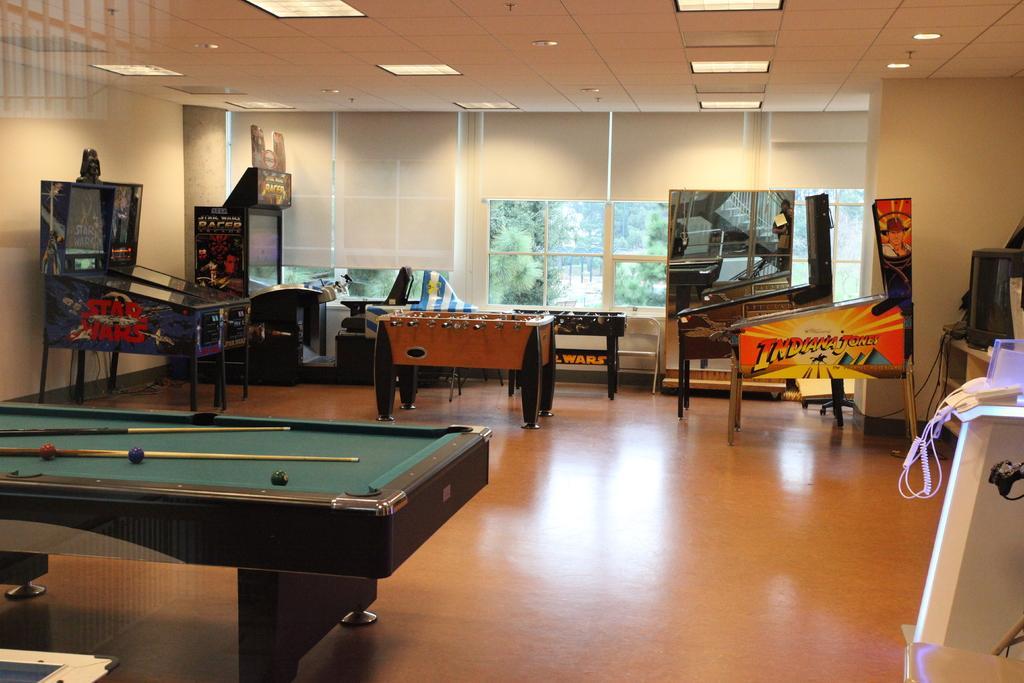Could you give a brief overview of what you see in this image? This is an inside view of a room. Here I can see a billiard table, mini football tables and some other games. On the right side there is a table on which few objects are placed. In the background there is a window. At the top of the image I can see the lights to the roof. 